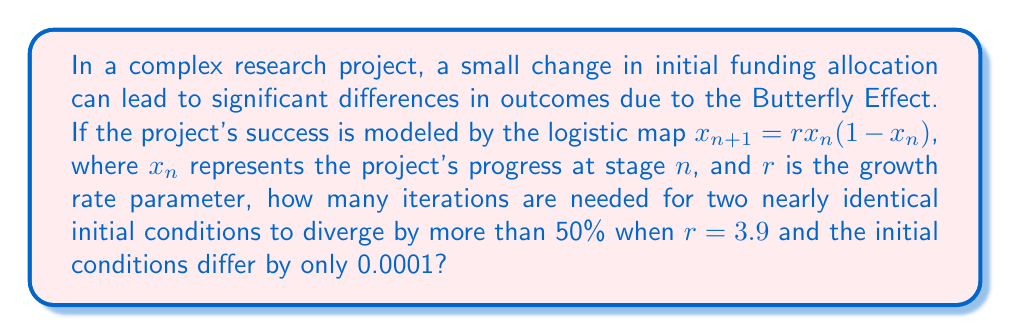Provide a solution to this math problem. To solve this problem, we'll follow these steps:

1) Let's start with two initial conditions: $x_0 = 0.5$ and $y_0 = 0.5001$

2) We'll iterate both sequences using the logistic map equation:
   $x_{n+1} = 3.9x_n(1-x_n)$
   $y_{n+1} = 3.9y_n(1-y_n)$

3) We'll calculate the difference $|x_n - y_n|$ at each iteration.

4) We'll stop when $|x_n - y_n| > 0.5$ (50% divergence).

Here's the iteration process:

n = 0: 
$x_0 = 0.5$, $y_0 = 0.5001$
$|x_0 - y_0| = 0.0001$

n = 1:
$x_1 = 3.9(0.5)(1-0.5) = 0.975$
$y_1 = 3.9(0.5001)(1-0.5001) = 0.974961$
$|x_1 - y_1| = 0.000039$

n = 2:
$x_2 = 3.9(0.975)(1-0.975) = 0.094744$
$y_2 = 3.9(0.974961)(1-0.974961) = 0.094859$
$|x_2 - y_2| = 0.000115$

...

n = 13:
$x_{13} ≈ 0.906357$
$y_{13} ≈ 0.363701$
$|x_{13} - y_{13}| ≈ 0.542656 > 0.5$

Therefore, it takes 13 iterations for the two sequences to diverge by more than 50%.
Answer: 13 iterations 